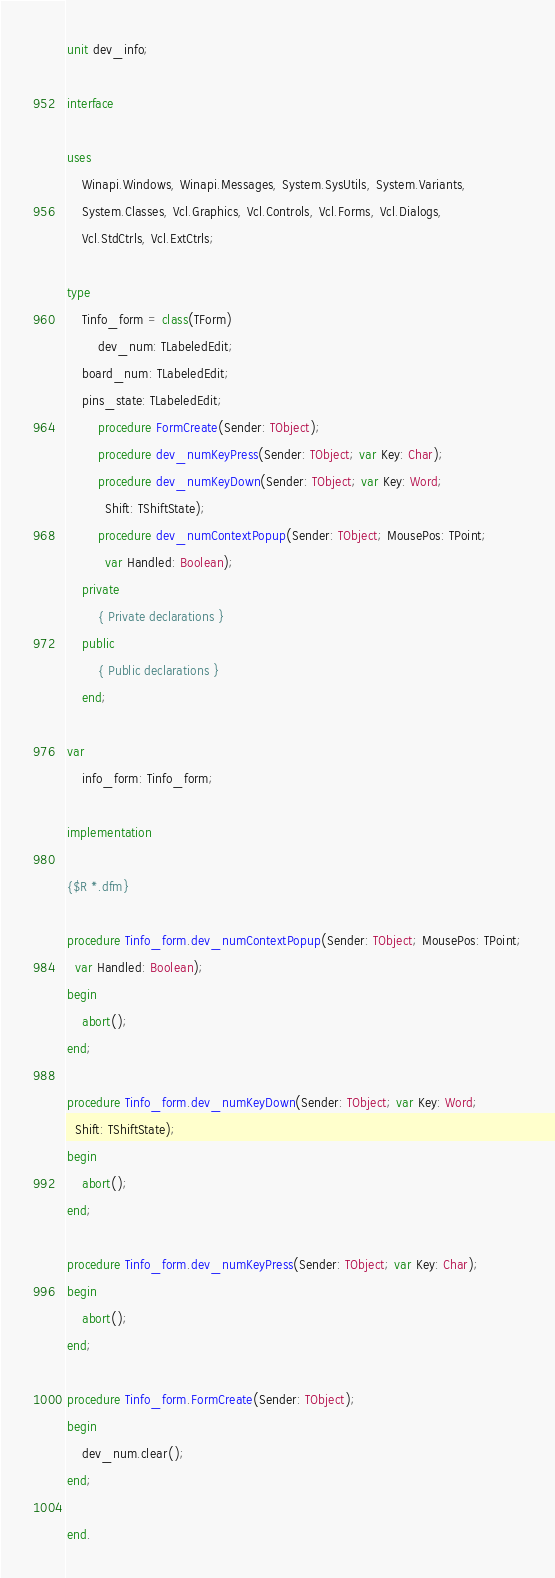Convert code to text. <code><loc_0><loc_0><loc_500><loc_500><_Pascal_>unit dev_info;

interface

uses
    Winapi.Windows, Winapi.Messages, System.SysUtils, System.Variants,
    System.Classes, Vcl.Graphics, Vcl.Controls, Vcl.Forms, Vcl.Dialogs,
    Vcl.StdCtrls, Vcl.ExtCtrls;

type
    Tinfo_form = class(TForm)
        dev_num: TLabeledEdit;
    board_num: TLabeledEdit;
    pins_state: TLabeledEdit;
        procedure FormCreate(Sender: TObject);
        procedure dev_numKeyPress(Sender: TObject; var Key: Char);
        procedure dev_numKeyDown(Sender: TObject; var Key: Word;
          Shift: TShiftState);
        procedure dev_numContextPopup(Sender: TObject; MousePos: TPoint;
          var Handled: Boolean);
    private
        { Private declarations }
    public
        { Public declarations }
    end;

var
    info_form: Tinfo_form;

implementation

{$R *.dfm}

procedure Tinfo_form.dev_numContextPopup(Sender: TObject; MousePos: TPoint;
  var Handled: Boolean);
begin
    abort();
end;

procedure Tinfo_form.dev_numKeyDown(Sender: TObject; var Key: Word;
  Shift: TShiftState);
begin
    abort();
end;

procedure Tinfo_form.dev_numKeyPress(Sender: TObject; var Key: Char);
begin
    abort();
end;

procedure Tinfo_form.FormCreate(Sender: TObject);
begin
    dev_num.clear();
end;

end.
</code> 